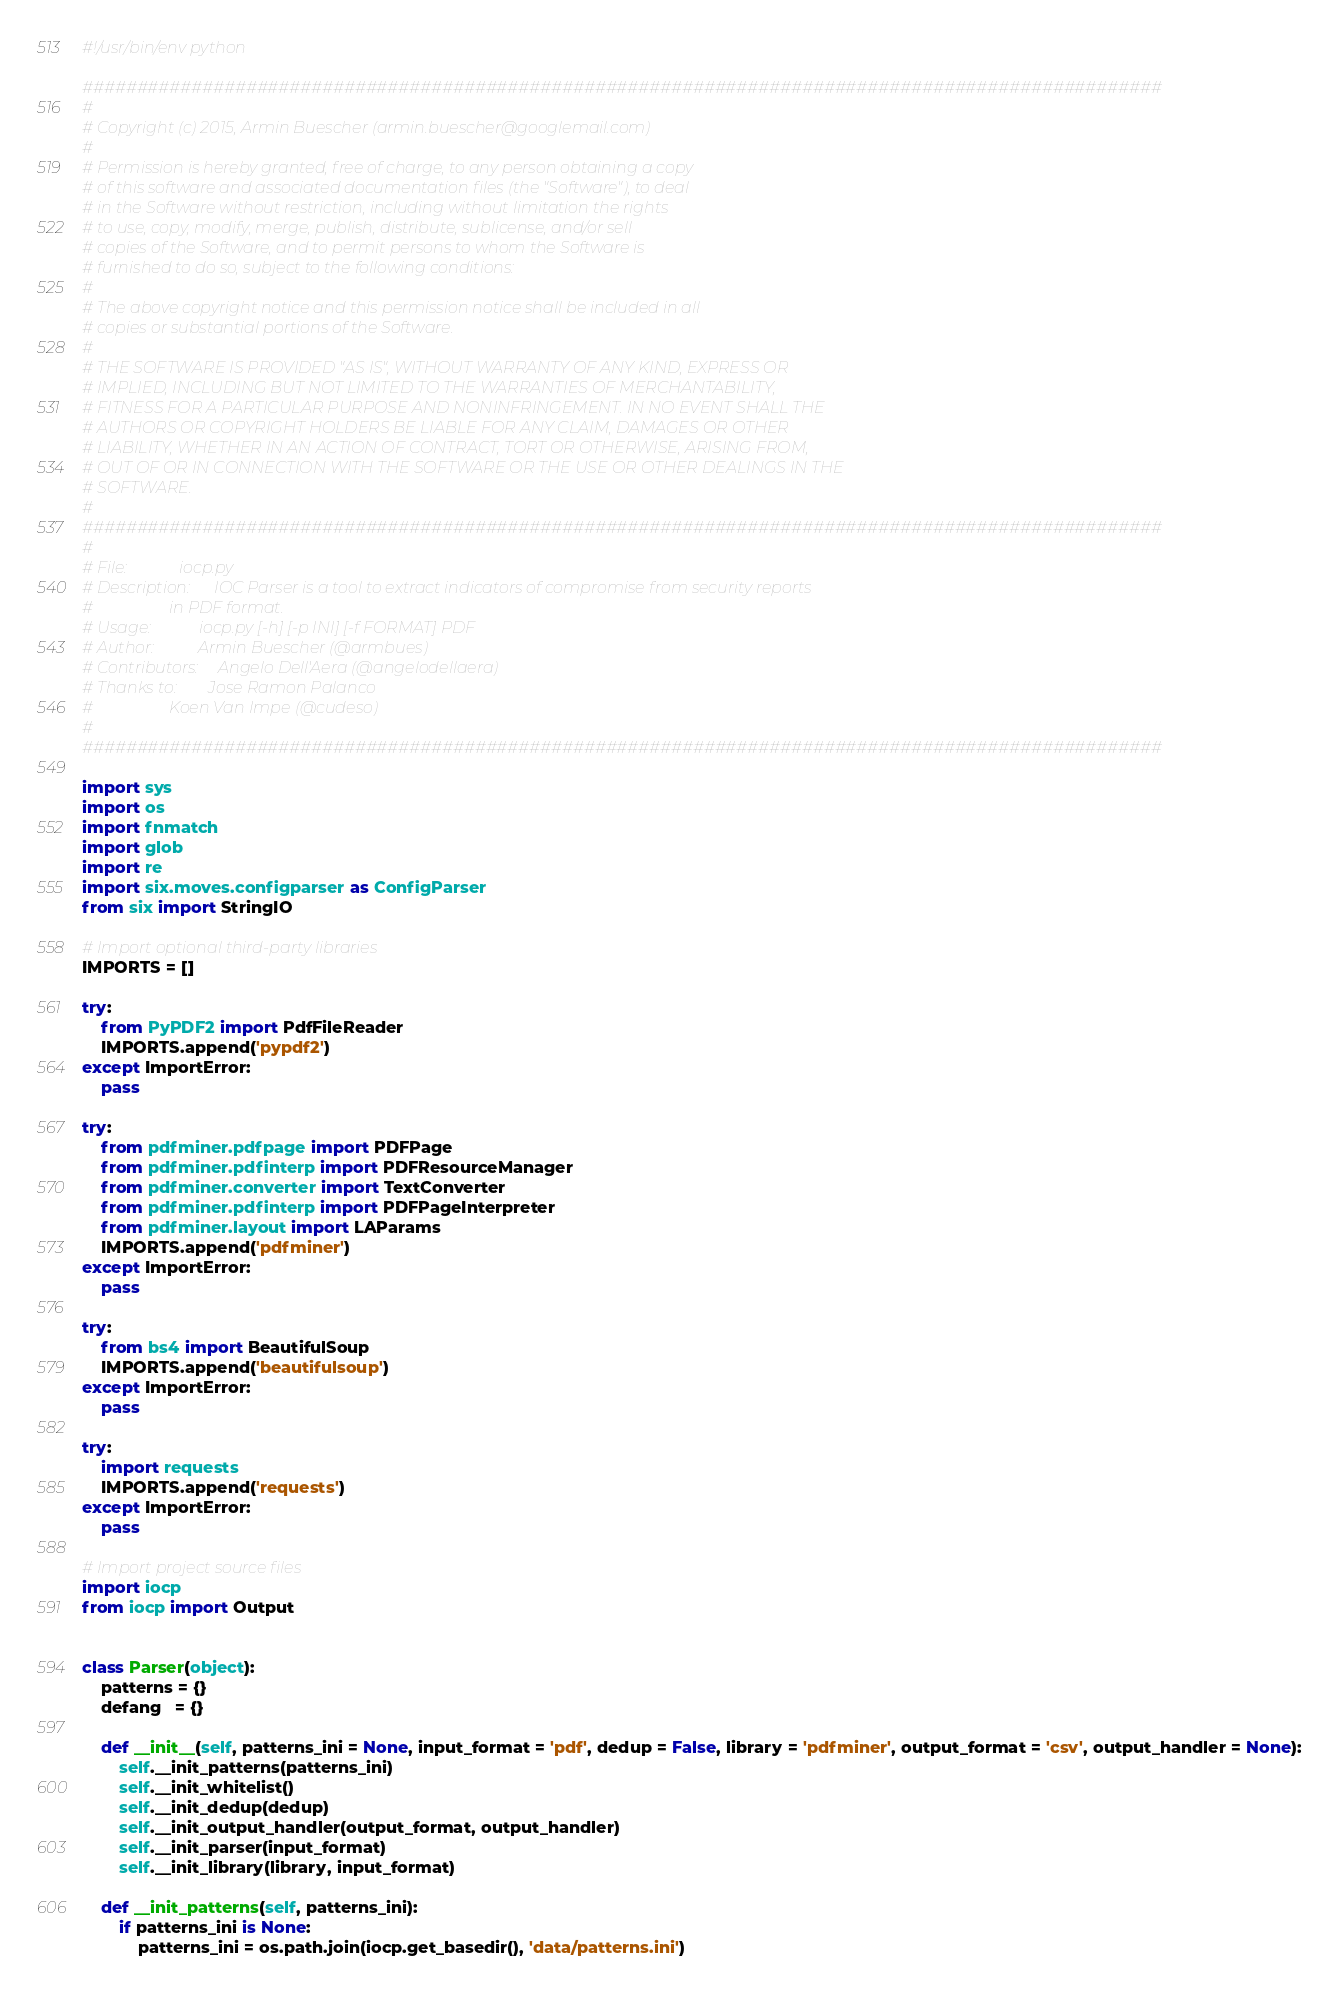Convert code to text. <code><loc_0><loc_0><loc_500><loc_500><_Python_>#!/usr/bin/env python

###################################################################################################
#
# Copyright (c) 2015, Armin Buescher (armin.buescher@googlemail.com)
#
# Permission is hereby granted, free of charge, to any person obtaining a copy
# of this software and associated documentation files (the "Software"), to deal
# in the Software without restriction, including without limitation the rights
# to use, copy, modify, merge, publish, distribute, sublicense, and/or sell
# copies of the Software, and to permit persons to whom the Software is
# furnished to do so, subject to the following conditions:
#
# The above copyright notice and this permission notice shall be included in all
# copies or substantial portions of the Software.
#
# THE SOFTWARE IS PROVIDED "AS IS", WITHOUT WARRANTY OF ANY KIND, EXPRESS OR
# IMPLIED, INCLUDING BUT NOT LIMITED TO THE WARRANTIES OF MERCHANTABILITY,
# FITNESS FOR A PARTICULAR PURPOSE AND NONINFRINGEMENT. IN NO EVENT SHALL THE
# AUTHORS OR COPYRIGHT HOLDERS BE LIABLE FOR ANY CLAIM, DAMAGES OR OTHER
# LIABILITY, WHETHER IN AN ACTION OF CONTRACT, TORT OR OTHERWISE, ARISING FROM,
# OUT OF OR IN CONNECTION WITH THE SOFTWARE OR THE USE OR OTHER DEALINGS IN THE
# SOFTWARE.
#
###################################################################################################
#
# File:             iocp.py
# Description:      IOC Parser is a tool to extract indicators of compromise from security reports
#                   in PDF format.
# Usage:            iocp.py [-h] [-p INI] [-f FORMAT] PDF
# Author:           Armin Buescher (@armbues)
# Contributors:     Angelo Dell'Aera (@angelodellaera)
# Thanks to:        Jose Ramon Palanco
#                   Koen Van Impe (@cudeso)
#
###################################################################################################

import sys
import os
import fnmatch
import glob
import re
import six.moves.configparser as ConfigParser
from six import StringIO

# Import optional third-party libraries
IMPORTS = []

try:
    from PyPDF2 import PdfFileReader
    IMPORTS.append('pypdf2')
except ImportError:
    pass

try:
    from pdfminer.pdfpage import PDFPage
    from pdfminer.pdfinterp import PDFResourceManager
    from pdfminer.converter import TextConverter
    from pdfminer.pdfinterp import PDFPageInterpreter
    from pdfminer.layout import LAParams
    IMPORTS.append('pdfminer')
except ImportError:
    pass

try:
    from bs4 import BeautifulSoup
    IMPORTS.append('beautifulsoup')
except ImportError:
    pass

try:
    import requests
    IMPORTS.append('requests')
except ImportError:
    pass

# Import project source files
import iocp
from iocp import Output


class Parser(object):
    patterns = {}
    defang   = {}

    def __init__(self, patterns_ini = None, input_format = 'pdf', dedup = False, library = 'pdfminer', output_format = 'csv', output_handler = None):
        self.__init_patterns(patterns_ini)
        self.__init_whitelist()
        self.__init_dedup(dedup)
        self.__init_output_handler(output_format, output_handler)
        self.__init_parser(input_format)
        self.__init_library(library, input_format)

    def __init_patterns(self, patterns_ini):
        if patterns_ini is None:
            patterns_ini = os.path.join(iocp.get_basedir(), 'data/patterns.ini')
</code> 